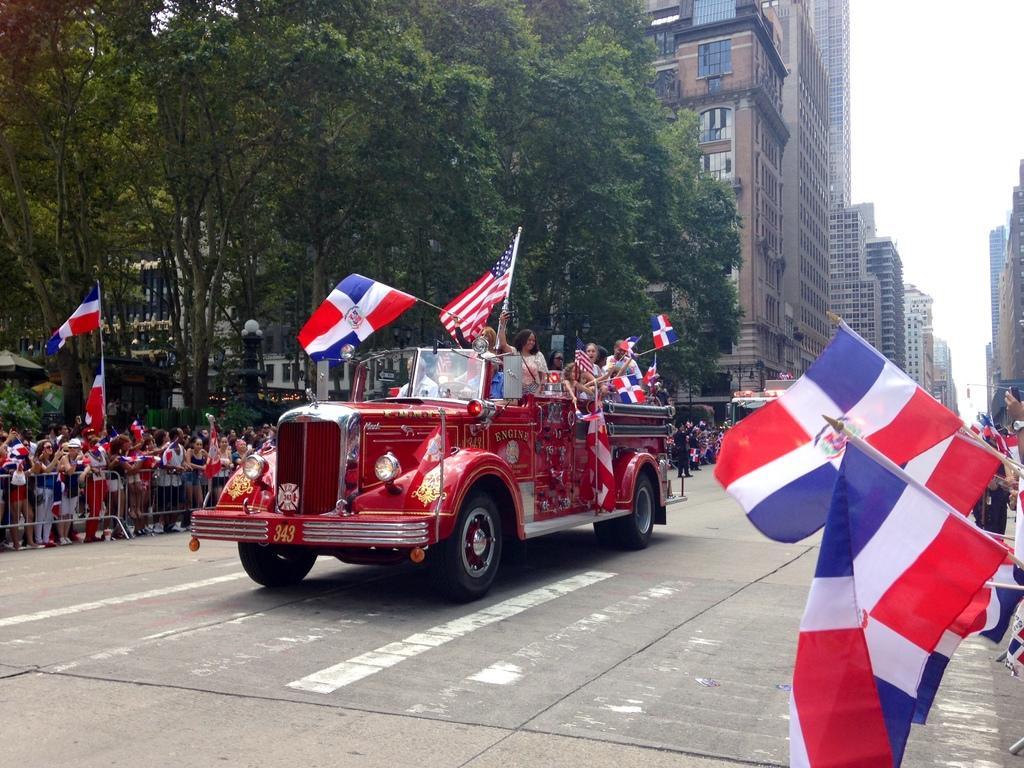In one or two sentences, can you explain what this image depicts? In this image, we can see persons holding flags. There is a vehicle on the road. There are trees and buildings in the middle of the image. There is a sky in the top right of the image. 